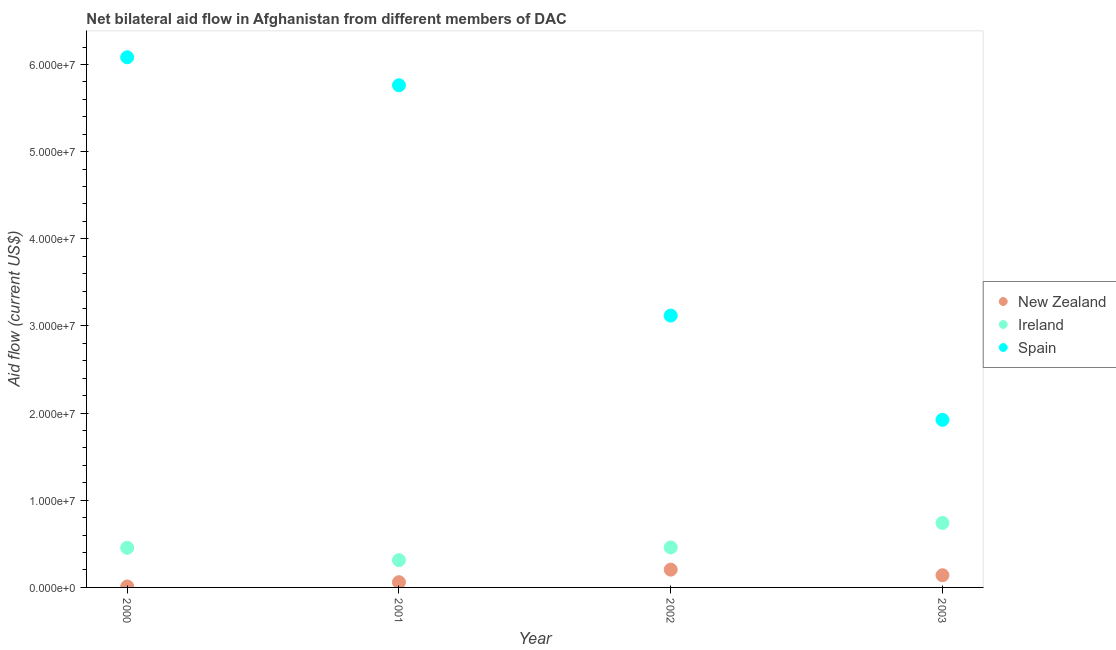What is the amount of aid provided by spain in 2002?
Offer a very short reply. 3.12e+07. Across all years, what is the maximum amount of aid provided by new zealand?
Provide a succinct answer. 2.04e+06. Across all years, what is the minimum amount of aid provided by ireland?
Give a very brief answer. 3.13e+06. In which year was the amount of aid provided by new zealand minimum?
Offer a very short reply. 2000. What is the total amount of aid provided by spain in the graph?
Offer a terse response. 1.69e+08. What is the difference between the amount of aid provided by ireland in 2000 and that in 2002?
Offer a terse response. -4.00e+04. What is the difference between the amount of aid provided by ireland in 2003 and the amount of aid provided by spain in 2000?
Offer a terse response. -5.34e+07. What is the average amount of aid provided by ireland per year?
Your response must be concise. 4.92e+06. In the year 2003, what is the difference between the amount of aid provided by ireland and amount of aid provided by new zealand?
Offer a very short reply. 6.00e+06. What is the ratio of the amount of aid provided by new zealand in 2000 to that in 2003?
Your answer should be compact. 0.08. Is the difference between the amount of aid provided by ireland in 2000 and 2002 greater than the difference between the amount of aid provided by spain in 2000 and 2002?
Provide a succinct answer. No. What is the difference between the highest and the second highest amount of aid provided by spain?
Your response must be concise. 3.21e+06. What is the difference between the highest and the lowest amount of aid provided by spain?
Ensure brevity in your answer.  4.16e+07. Is the sum of the amount of aid provided by ireland in 2000 and 2002 greater than the maximum amount of aid provided by new zealand across all years?
Keep it short and to the point. Yes. Does the amount of aid provided by ireland monotonically increase over the years?
Your answer should be compact. No. Is the amount of aid provided by ireland strictly less than the amount of aid provided by new zealand over the years?
Give a very brief answer. No. How many dotlines are there?
Make the answer very short. 3. Where does the legend appear in the graph?
Ensure brevity in your answer.  Center right. What is the title of the graph?
Your response must be concise. Net bilateral aid flow in Afghanistan from different members of DAC. What is the Aid flow (current US$) in Ireland in 2000?
Your answer should be very brief. 4.55e+06. What is the Aid flow (current US$) of Spain in 2000?
Offer a very short reply. 6.08e+07. What is the Aid flow (current US$) of Ireland in 2001?
Keep it short and to the point. 3.13e+06. What is the Aid flow (current US$) in Spain in 2001?
Your response must be concise. 5.76e+07. What is the Aid flow (current US$) in New Zealand in 2002?
Provide a short and direct response. 2.04e+06. What is the Aid flow (current US$) in Ireland in 2002?
Your answer should be very brief. 4.59e+06. What is the Aid flow (current US$) of Spain in 2002?
Your answer should be compact. 3.12e+07. What is the Aid flow (current US$) in New Zealand in 2003?
Give a very brief answer. 1.40e+06. What is the Aid flow (current US$) of Ireland in 2003?
Make the answer very short. 7.40e+06. What is the Aid flow (current US$) in Spain in 2003?
Keep it short and to the point. 1.92e+07. Across all years, what is the maximum Aid flow (current US$) of New Zealand?
Ensure brevity in your answer.  2.04e+06. Across all years, what is the maximum Aid flow (current US$) of Ireland?
Your answer should be very brief. 7.40e+06. Across all years, what is the maximum Aid flow (current US$) of Spain?
Give a very brief answer. 6.08e+07. Across all years, what is the minimum Aid flow (current US$) of Ireland?
Offer a terse response. 3.13e+06. Across all years, what is the minimum Aid flow (current US$) of Spain?
Your answer should be compact. 1.92e+07. What is the total Aid flow (current US$) in New Zealand in the graph?
Offer a very short reply. 4.15e+06. What is the total Aid flow (current US$) in Ireland in the graph?
Offer a very short reply. 1.97e+07. What is the total Aid flow (current US$) in Spain in the graph?
Offer a very short reply. 1.69e+08. What is the difference between the Aid flow (current US$) of New Zealand in 2000 and that in 2001?
Provide a short and direct response. -4.90e+05. What is the difference between the Aid flow (current US$) in Ireland in 2000 and that in 2001?
Make the answer very short. 1.42e+06. What is the difference between the Aid flow (current US$) in Spain in 2000 and that in 2001?
Offer a terse response. 3.21e+06. What is the difference between the Aid flow (current US$) in New Zealand in 2000 and that in 2002?
Make the answer very short. -1.93e+06. What is the difference between the Aid flow (current US$) in Spain in 2000 and that in 2002?
Your answer should be compact. 2.96e+07. What is the difference between the Aid flow (current US$) of New Zealand in 2000 and that in 2003?
Provide a succinct answer. -1.29e+06. What is the difference between the Aid flow (current US$) in Ireland in 2000 and that in 2003?
Your response must be concise. -2.85e+06. What is the difference between the Aid flow (current US$) in Spain in 2000 and that in 2003?
Provide a short and direct response. 4.16e+07. What is the difference between the Aid flow (current US$) of New Zealand in 2001 and that in 2002?
Ensure brevity in your answer.  -1.44e+06. What is the difference between the Aid flow (current US$) of Ireland in 2001 and that in 2002?
Ensure brevity in your answer.  -1.46e+06. What is the difference between the Aid flow (current US$) of Spain in 2001 and that in 2002?
Make the answer very short. 2.64e+07. What is the difference between the Aid flow (current US$) of New Zealand in 2001 and that in 2003?
Offer a terse response. -8.00e+05. What is the difference between the Aid flow (current US$) in Ireland in 2001 and that in 2003?
Your answer should be very brief. -4.27e+06. What is the difference between the Aid flow (current US$) of Spain in 2001 and that in 2003?
Make the answer very short. 3.84e+07. What is the difference between the Aid flow (current US$) of New Zealand in 2002 and that in 2003?
Your answer should be compact. 6.40e+05. What is the difference between the Aid flow (current US$) in Ireland in 2002 and that in 2003?
Your response must be concise. -2.81e+06. What is the difference between the Aid flow (current US$) in Spain in 2002 and that in 2003?
Your answer should be compact. 1.20e+07. What is the difference between the Aid flow (current US$) in New Zealand in 2000 and the Aid flow (current US$) in Ireland in 2001?
Your response must be concise. -3.02e+06. What is the difference between the Aid flow (current US$) in New Zealand in 2000 and the Aid flow (current US$) in Spain in 2001?
Ensure brevity in your answer.  -5.75e+07. What is the difference between the Aid flow (current US$) in Ireland in 2000 and the Aid flow (current US$) in Spain in 2001?
Your response must be concise. -5.31e+07. What is the difference between the Aid flow (current US$) in New Zealand in 2000 and the Aid flow (current US$) in Ireland in 2002?
Provide a short and direct response. -4.48e+06. What is the difference between the Aid flow (current US$) in New Zealand in 2000 and the Aid flow (current US$) in Spain in 2002?
Give a very brief answer. -3.11e+07. What is the difference between the Aid flow (current US$) in Ireland in 2000 and the Aid flow (current US$) in Spain in 2002?
Make the answer very short. -2.66e+07. What is the difference between the Aid flow (current US$) of New Zealand in 2000 and the Aid flow (current US$) of Ireland in 2003?
Ensure brevity in your answer.  -7.29e+06. What is the difference between the Aid flow (current US$) of New Zealand in 2000 and the Aid flow (current US$) of Spain in 2003?
Make the answer very short. -1.91e+07. What is the difference between the Aid flow (current US$) in Ireland in 2000 and the Aid flow (current US$) in Spain in 2003?
Provide a short and direct response. -1.47e+07. What is the difference between the Aid flow (current US$) in New Zealand in 2001 and the Aid flow (current US$) in Ireland in 2002?
Offer a terse response. -3.99e+06. What is the difference between the Aid flow (current US$) of New Zealand in 2001 and the Aid flow (current US$) of Spain in 2002?
Offer a terse response. -3.06e+07. What is the difference between the Aid flow (current US$) of Ireland in 2001 and the Aid flow (current US$) of Spain in 2002?
Your answer should be very brief. -2.81e+07. What is the difference between the Aid flow (current US$) of New Zealand in 2001 and the Aid flow (current US$) of Ireland in 2003?
Your answer should be compact. -6.80e+06. What is the difference between the Aid flow (current US$) in New Zealand in 2001 and the Aid flow (current US$) in Spain in 2003?
Keep it short and to the point. -1.86e+07. What is the difference between the Aid flow (current US$) of Ireland in 2001 and the Aid flow (current US$) of Spain in 2003?
Provide a short and direct response. -1.61e+07. What is the difference between the Aid flow (current US$) of New Zealand in 2002 and the Aid flow (current US$) of Ireland in 2003?
Provide a short and direct response. -5.36e+06. What is the difference between the Aid flow (current US$) in New Zealand in 2002 and the Aid flow (current US$) in Spain in 2003?
Keep it short and to the point. -1.72e+07. What is the difference between the Aid flow (current US$) of Ireland in 2002 and the Aid flow (current US$) of Spain in 2003?
Your response must be concise. -1.46e+07. What is the average Aid flow (current US$) in New Zealand per year?
Ensure brevity in your answer.  1.04e+06. What is the average Aid flow (current US$) in Ireland per year?
Give a very brief answer. 4.92e+06. What is the average Aid flow (current US$) in Spain per year?
Provide a short and direct response. 4.22e+07. In the year 2000, what is the difference between the Aid flow (current US$) of New Zealand and Aid flow (current US$) of Ireland?
Ensure brevity in your answer.  -4.44e+06. In the year 2000, what is the difference between the Aid flow (current US$) in New Zealand and Aid flow (current US$) in Spain?
Provide a succinct answer. -6.07e+07. In the year 2000, what is the difference between the Aid flow (current US$) in Ireland and Aid flow (current US$) in Spain?
Offer a very short reply. -5.63e+07. In the year 2001, what is the difference between the Aid flow (current US$) of New Zealand and Aid flow (current US$) of Ireland?
Your response must be concise. -2.53e+06. In the year 2001, what is the difference between the Aid flow (current US$) of New Zealand and Aid flow (current US$) of Spain?
Make the answer very short. -5.70e+07. In the year 2001, what is the difference between the Aid flow (current US$) of Ireland and Aid flow (current US$) of Spain?
Ensure brevity in your answer.  -5.45e+07. In the year 2002, what is the difference between the Aid flow (current US$) of New Zealand and Aid flow (current US$) of Ireland?
Your response must be concise. -2.55e+06. In the year 2002, what is the difference between the Aid flow (current US$) of New Zealand and Aid flow (current US$) of Spain?
Offer a terse response. -2.92e+07. In the year 2002, what is the difference between the Aid flow (current US$) of Ireland and Aid flow (current US$) of Spain?
Your answer should be compact. -2.66e+07. In the year 2003, what is the difference between the Aid flow (current US$) of New Zealand and Aid flow (current US$) of Ireland?
Provide a succinct answer. -6.00e+06. In the year 2003, what is the difference between the Aid flow (current US$) of New Zealand and Aid flow (current US$) of Spain?
Make the answer very short. -1.78e+07. In the year 2003, what is the difference between the Aid flow (current US$) in Ireland and Aid flow (current US$) in Spain?
Offer a terse response. -1.18e+07. What is the ratio of the Aid flow (current US$) of New Zealand in 2000 to that in 2001?
Keep it short and to the point. 0.18. What is the ratio of the Aid flow (current US$) of Ireland in 2000 to that in 2001?
Make the answer very short. 1.45. What is the ratio of the Aid flow (current US$) in Spain in 2000 to that in 2001?
Give a very brief answer. 1.06. What is the ratio of the Aid flow (current US$) of New Zealand in 2000 to that in 2002?
Ensure brevity in your answer.  0.05. What is the ratio of the Aid flow (current US$) in Spain in 2000 to that in 2002?
Provide a short and direct response. 1.95. What is the ratio of the Aid flow (current US$) in New Zealand in 2000 to that in 2003?
Ensure brevity in your answer.  0.08. What is the ratio of the Aid flow (current US$) of Ireland in 2000 to that in 2003?
Your response must be concise. 0.61. What is the ratio of the Aid flow (current US$) in Spain in 2000 to that in 2003?
Provide a succinct answer. 3.16. What is the ratio of the Aid flow (current US$) of New Zealand in 2001 to that in 2002?
Offer a terse response. 0.29. What is the ratio of the Aid flow (current US$) in Ireland in 2001 to that in 2002?
Provide a succinct answer. 0.68. What is the ratio of the Aid flow (current US$) in Spain in 2001 to that in 2002?
Your answer should be very brief. 1.85. What is the ratio of the Aid flow (current US$) in New Zealand in 2001 to that in 2003?
Offer a terse response. 0.43. What is the ratio of the Aid flow (current US$) of Ireland in 2001 to that in 2003?
Provide a succinct answer. 0.42. What is the ratio of the Aid flow (current US$) of Spain in 2001 to that in 2003?
Your response must be concise. 3. What is the ratio of the Aid flow (current US$) in New Zealand in 2002 to that in 2003?
Your response must be concise. 1.46. What is the ratio of the Aid flow (current US$) in Ireland in 2002 to that in 2003?
Your answer should be compact. 0.62. What is the ratio of the Aid flow (current US$) in Spain in 2002 to that in 2003?
Provide a short and direct response. 1.62. What is the difference between the highest and the second highest Aid flow (current US$) of New Zealand?
Your answer should be compact. 6.40e+05. What is the difference between the highest and the second highest Aid flow (current US$) of Ireland?
Ensure brevity in your answer.  2.81e+06. What is the difference between the highest and the second highest Aid flow (current US$) in Spain?
Offer a terse response. 3.21e+06. What is the difference between the highest and the lowest Aid flow (current US$) in New Zealand?
Offer a very short reply. 1.93e+06. What is the difference between the highest and the lowest Aid flow (current US$) in Ireland?
Your answer should be very brief. 4.27e+06. What is the difference between the highest and the lowest Aid flow (current US$) in Spain?
Your answer should be very brief. 4.16e+07. 